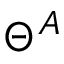Convert formula to latex. <formula><loc_0><loc_0><loc_500><loc_500>\Theta ^ { A }</formula> 